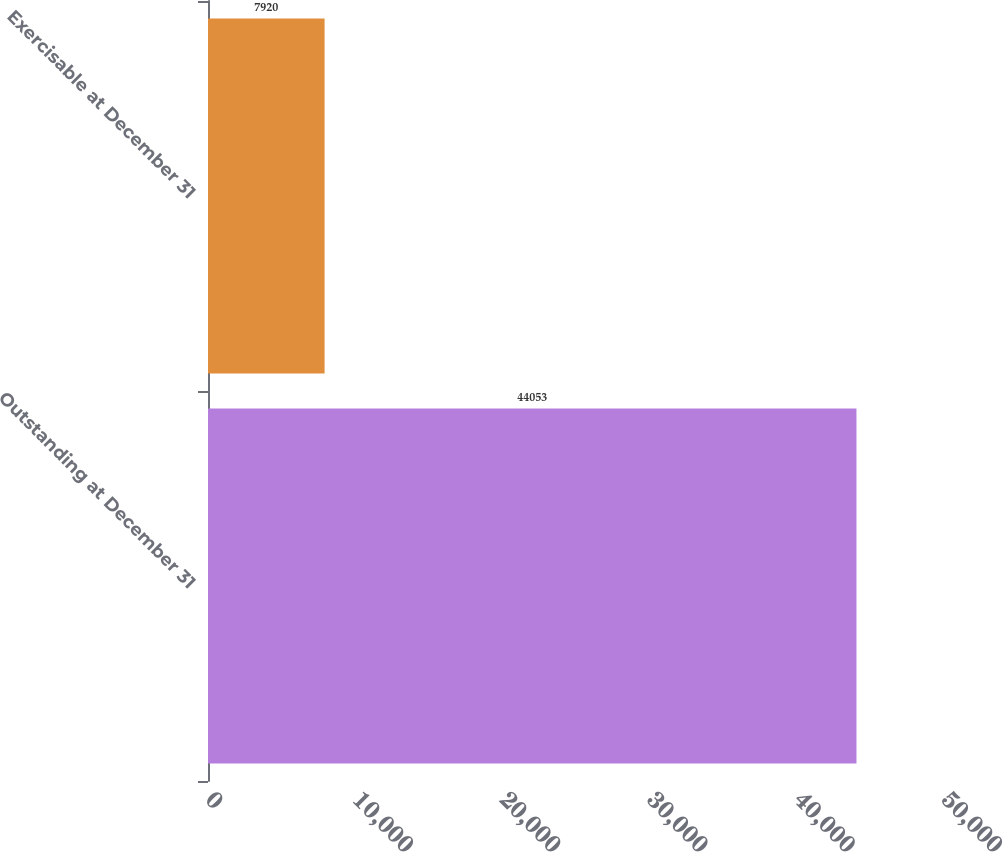Convert chart to OTSL. <chart><loc_0><loc_0><loc_500><loc_500><bar_chart><fcel>Outstanding at December 31<fcel>Exercisable at December 31<nl><fcel>44053<fcel>7920<nl></chart> 